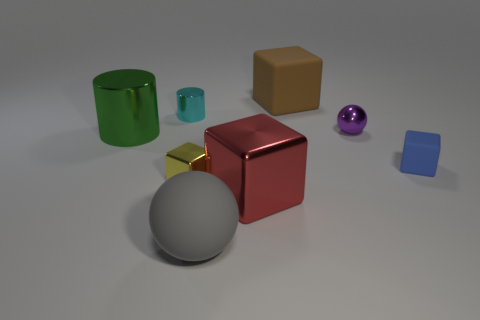Subtract all brown rubber blocks. How many blocks are left? 3 Add 1 brown cubes. How many objects exist? 9 Subtract all cylinders. How many objects are left? 6 Add 1 tiny yellow objects. How many tiny yellow objects are left? 2 Add 7 big matte cubes. How many big matte cubes exist? 8 Subtract all yellow blocks. How many blocks are left? 3 Subtract 1 yellow cubes. How many objects are left? 7 Subtract 1 spheres. How many spheres are left? 1 Subtract all brown spheres. Subtract all yellow cylinders. How many spheres are left? 2 Subtract all green spheres. How many green cubes are left? 0 